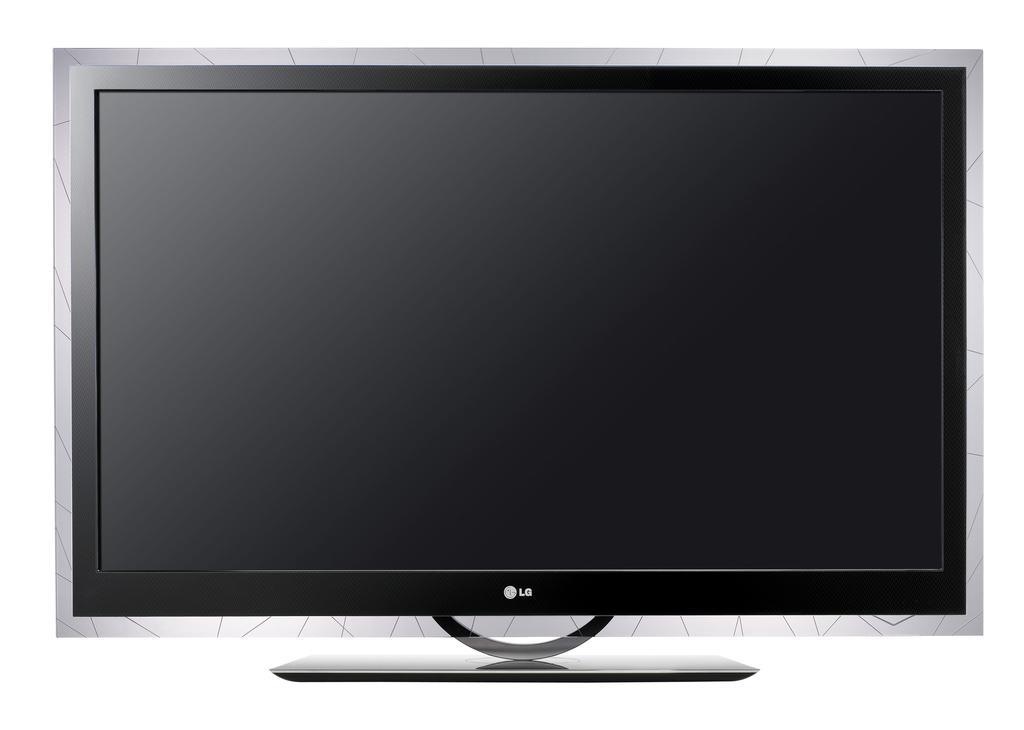How would you summarize this image in a sentence or two? There is a lg television and there is a white background. 